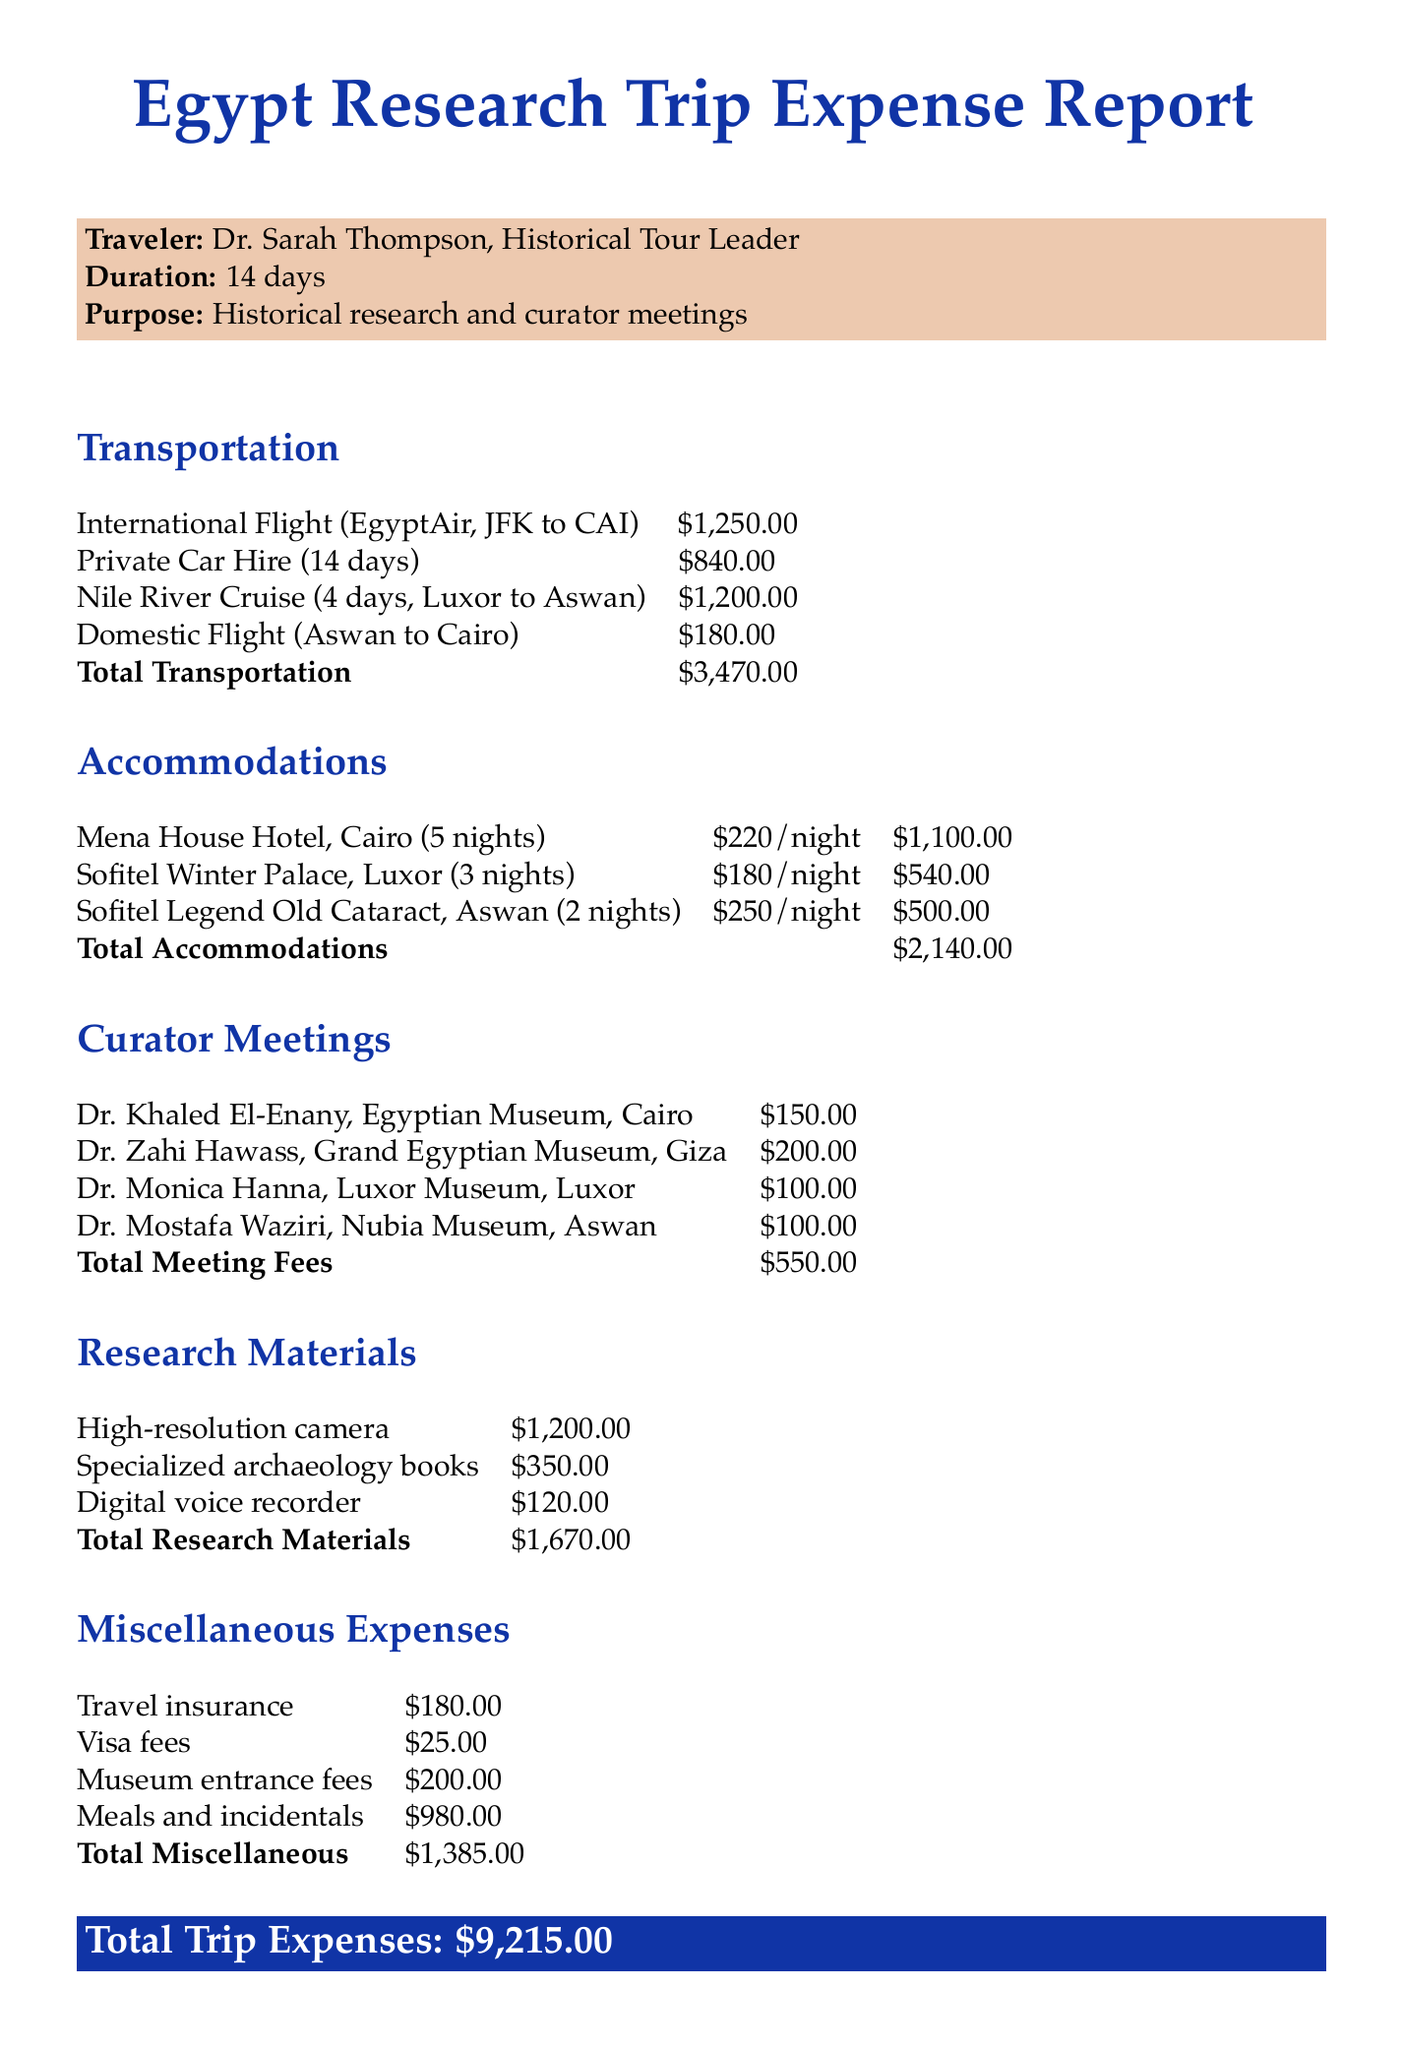What is the total cost of transportation? The total cost of transportation is the sum of all local and international transport expenses listed, which is $1250 + $840 + $1200 + $180 = $3470.
Answer: $3470 How many days was the trip duration? The trip duration is explicitly stated in the document as 14 days.
Answer: 14 days Who is the traveler listed in the document? The traveler's name is provided at the beginning, Dr. Sarah Thompson.
Answer: Dr. Sarah Thompson What is the cost of stayed at Mena House Hotel? The document specifies the cost per night and the total nights stayed, which sums up to $220 per night for 5 nights, totaling $1100.
Answer: $1100 Who was the curator met in Cairo? The document lists Dr. Khaled El-Enany as the curator met at the Egyptian Museum, which is located in Cairo.
Answer: Dr. Khaled El-Enany What was the cost of the Nile River cruise? The document states that the cost of the Nile River cruise for 4 days is $1200.
Answer: $1200 What is the total cost for research materials? The total cost of research materials is calculated from individual items totaling $1200 + $350 + $120, which equals $1670.
Answer: $1670 What were the miscellaneous expenses for travel insurance? The document lists travel insurance as a separate item with a cost of $180.
Answer: $180 How many nights were spent at the Sofitel Legend Old Cataract? The document clearly indicates 2 nights were spent at Sofitel Legend Old Cataract in Aswan.
Answer: 2 nights 